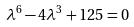<formula> <loc_0><loc_0><loc_500><loc_500>\lambda ^ { 6 } - 4 \lambda ^ { 3 } + 1 2 5 = 0</formula> 